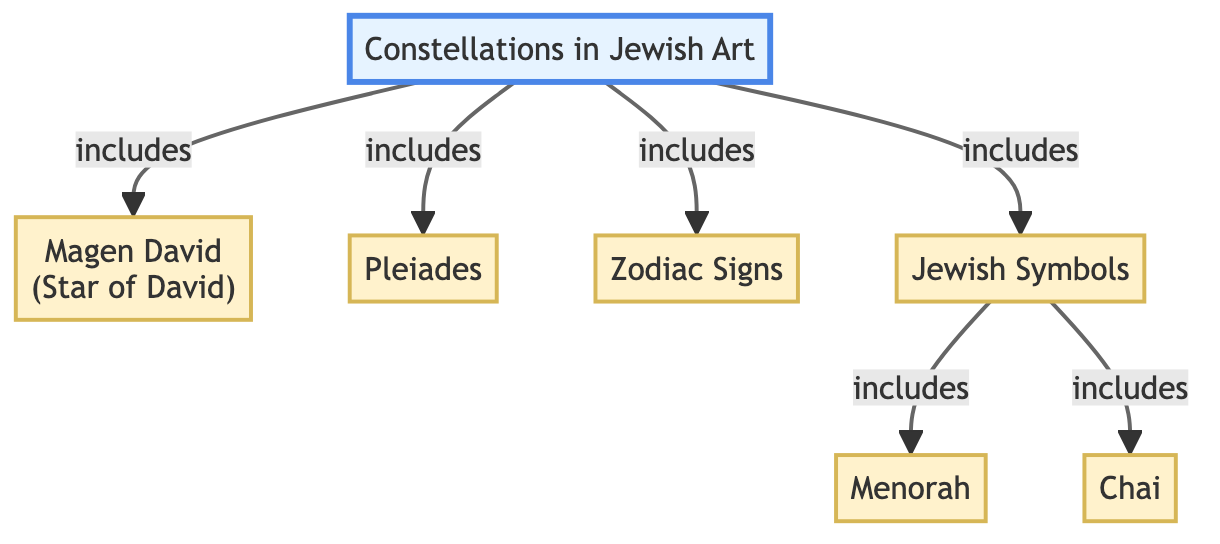What is the main focus of the diagram? The diagram centers around "Constellations in Jewish Art," which is the primary node from which all other elements branch out.
Answer: Constellations in Jewish Art How many symbols are directly connected to "Jewish Symbols"? The diagram shows three symbols directly connected to "Jewish Symbols": Menorah, Chai, and the Zodiac Signs.
Answer: 3 What symbol is represented by the value "2" in the flowchart? The symbol "Magen David" or Star of David is represented by node 2 in the flowchart, indicating its significance within the diagram's focus on constellations in Jewish art.
Answer: Magen David Which node immediately follows "Zodiac Signs"? The node that follows "Zodiac Signs" is "Jewish Symbols," which indicates that Zodiac Signs are part of the broader category of Jewish symbols in the diagram.
Answer: Jewish Symbols What is the relationship between "Constellations in Jewish Art" and "Zodiac Signs"? "Constellations in Jewish Art" directly includes "Zodiac Signs," illustrating that Zodiac Signs are considered part of the artistic representations of constellations within Jewish contexts.
Answer: includes When looking at the diagram, how many nodes represent symbols? There are five nodes that specifically represent different symbols: Magen David, Pleiades, Zodiac Signs, Menorah, and Chai, making a total of five symbol representations.
Answer: 5 Which symbol is visually represented as the first item under "Jewish Symbols"? The first item listed under "Jewish Symbols" is "Menorah," indicating its precedence in the context of symbols relevant to Jewish art and symbolism.
Answer: Menorah What do both "Chai" and "Pleiades" have in common according to the diagram? Both "Chai" and "Pleiades" are categories listed as symbols featured within the context of constellations in Jewish art, connecting them under the broader theme of symbolic representation.
Answer: Symbols How is the flow chart's main focus organized? The main focus is organized by including various related symbols and constellations under the overarching theme of Jewish art, indicating how different elements relate to each other in this context.
Answer: By connections in themes 